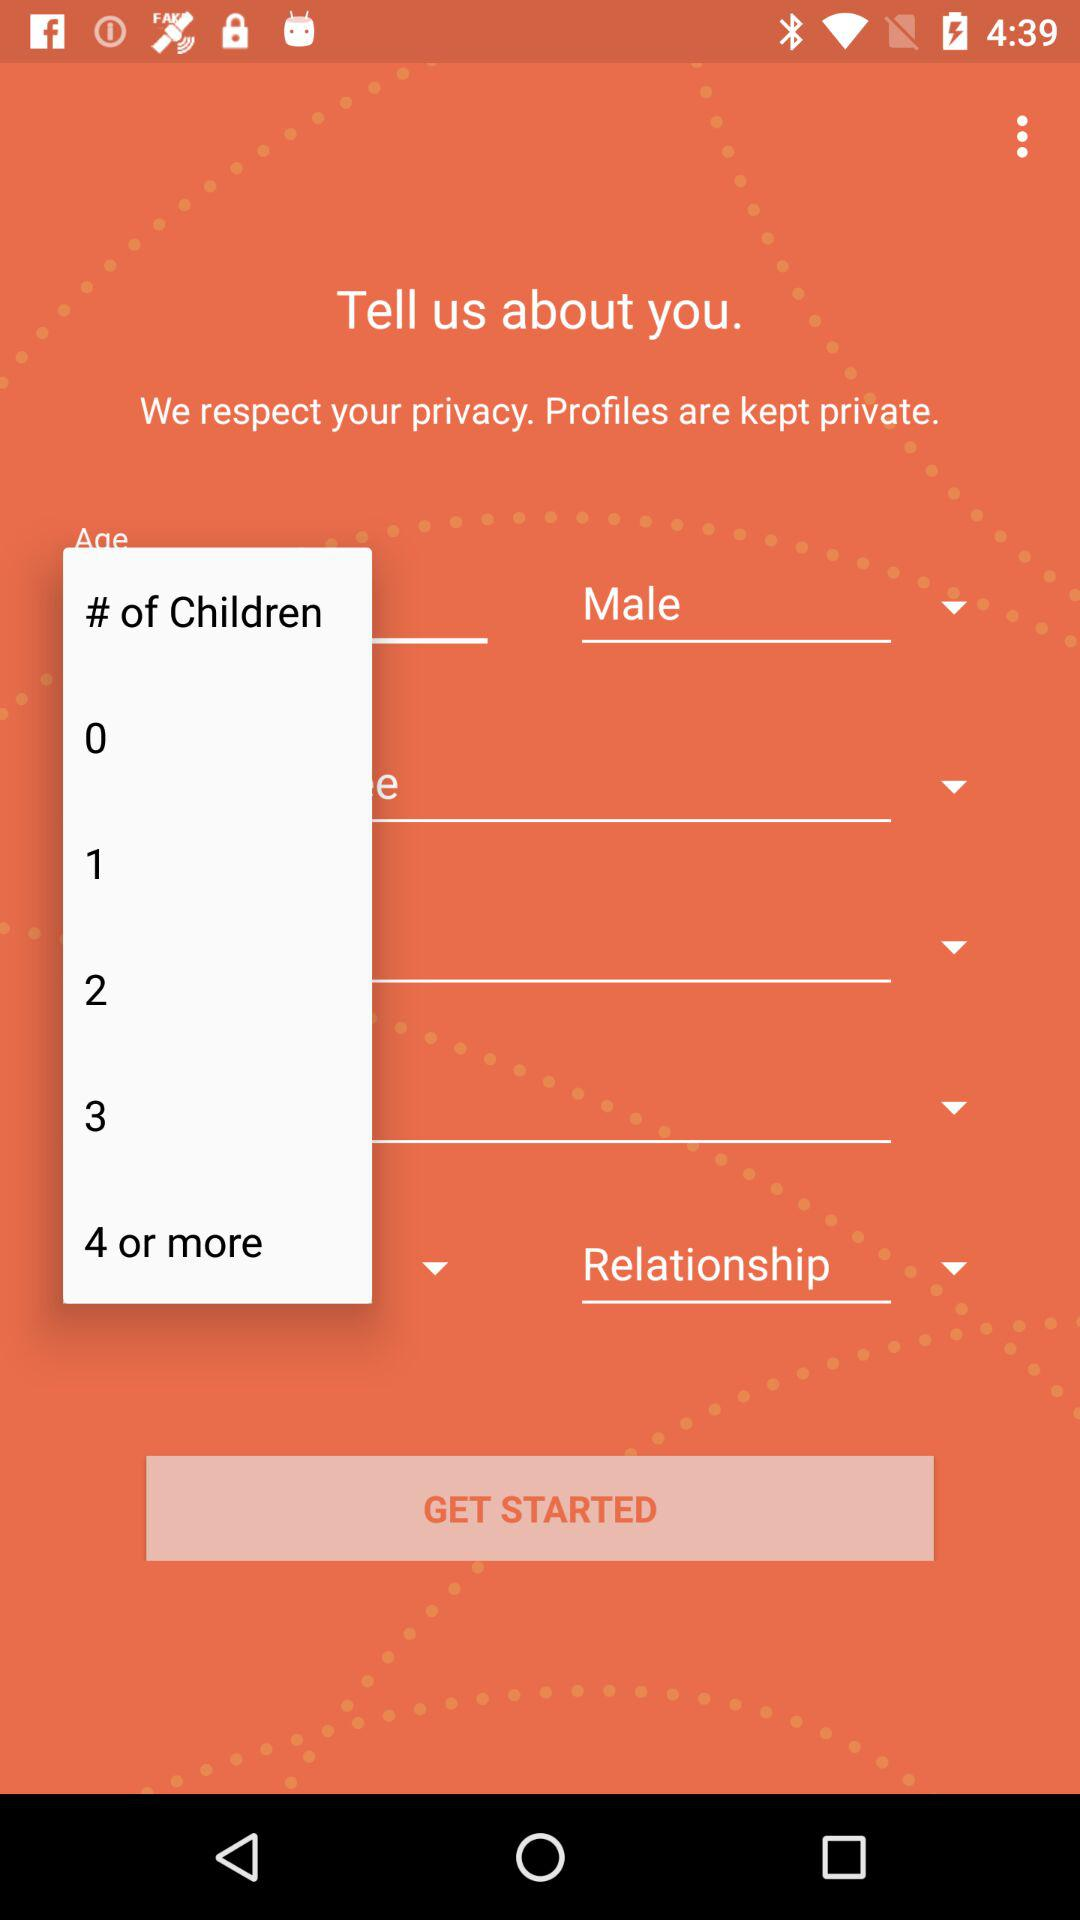How many options are available for the number of children?
Answer the question using a single word or phrase. 5 